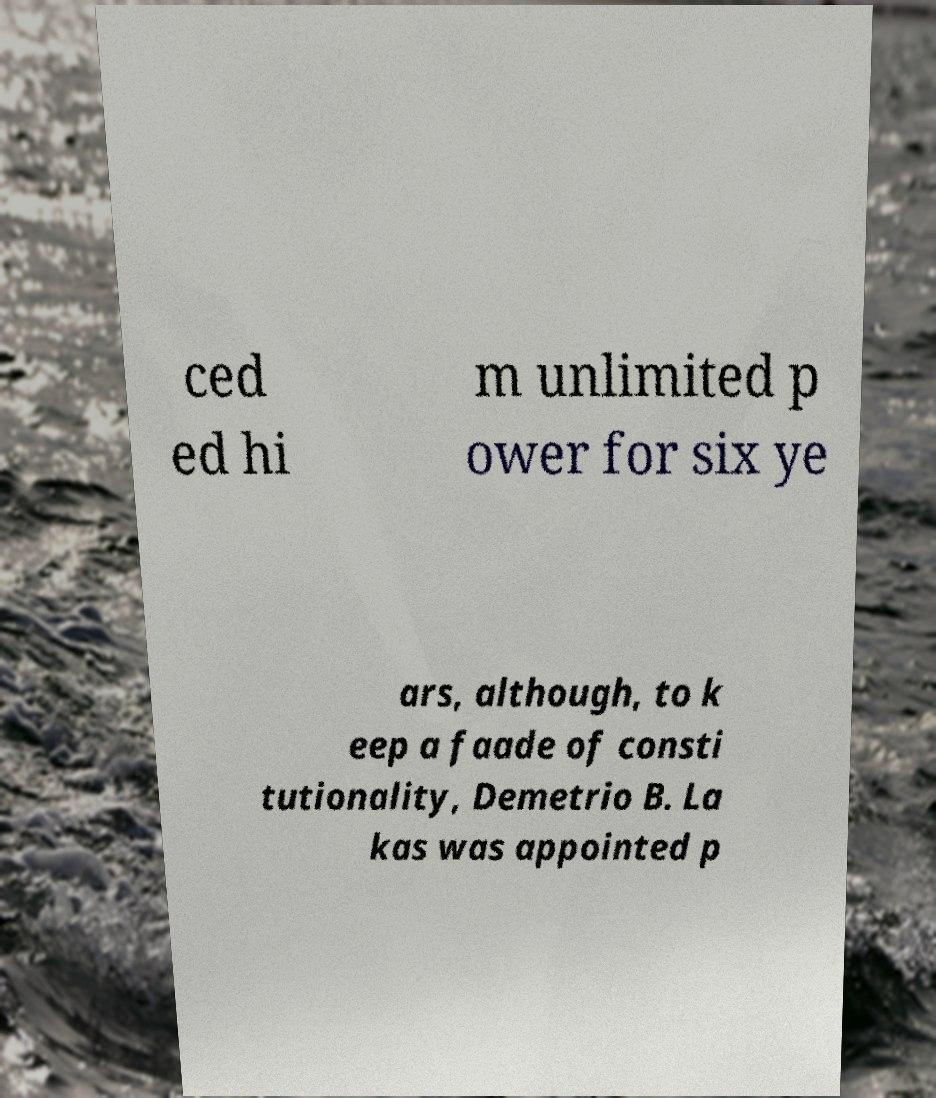Please read and relay the text visible in this image. What does it say? ced ed hi m unlimited p ower for six ye ars, although, to k eep a faade of consti tutionality, Demetrio B. La kas was appointed p 